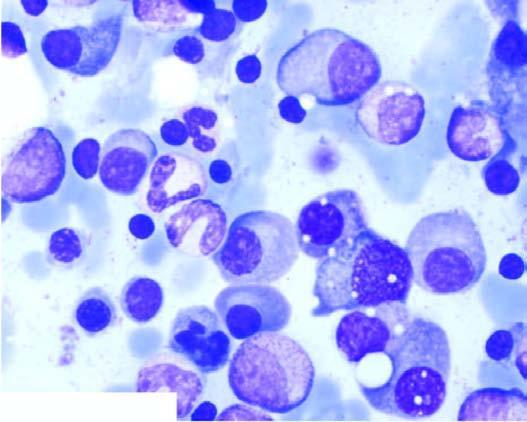does peripheral blood film show marked neutrophilic leucocytosis aspirate in myeloma showing numerous plasma cells, many with abnormal features?
Answer the question using a single word or phrase. No 